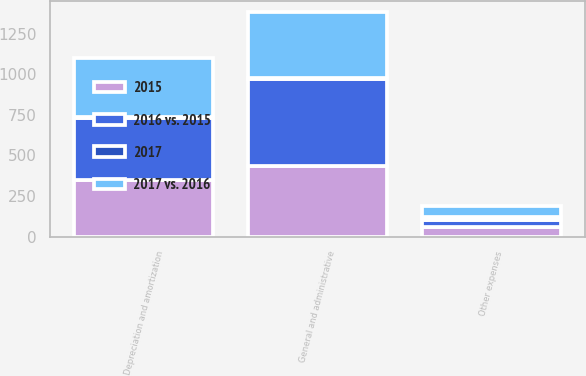Convert chart to OTSL. <chart><loc_0><loc_0><loc_500><loc_500><stacked_bar_chart><ecel><fcel>Depreciation and amortization<fcel>General and administrative<fcel>Other expenses<nl><fcel>2015<fcel>347<fcel>434<fcel>56<nl><fcel>2017 vs. 2016<fcel>364<fcel>403<fcel>66<nl><fcel>2016 vs. 2015<fcel>385<fcel>537<fcel>49<nl><fcel>2017<fcel>4.7<fcel>7.7<fcel>15.2<nl></chart> 